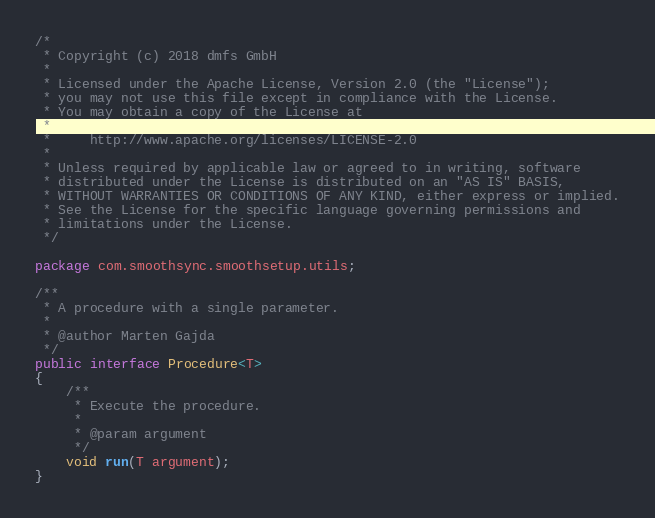<code> <loc_0><loc_0><loc_500><loc_500><_Java_>/*
 * Copyright (c) 2018 dmfs GmbH
 *
 * Licensed under the Apache License, Version 2.0 (the "License");
 * you may not use this file except in compliance with the License.
 * You may obtain a copy of the License at
 *
 *     http://www.apache.org/licenses/LICENSE-2.0
 *
 * Unless required by applicable law or agreed to in writing, software
 * distributed under the License is distributed on an "AS IS" BASIS,
 * WITHOUT WARRANTIES OR CONDITIONS OF ANY KIND, either express or implied.
 * See the License for the specific language governing permissions and
 * limitations under the License.
 */

package com.smoothsync.smoothsetup.utils;

/**
 * A procedure with a single parameter.
 *
 * @author Marten Gajda
 */
public interface Procedure<T>
{
    /**
     * Execute the procedure.
     *
     * @param argument
     */
    void run(T argument);
}
</code> 